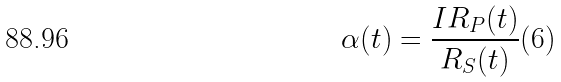Convert formula to latex. <formula><loc_0><loc_0><loc_500><loc_500>\alpha ( t ) = \frac { I R _ { P } ( t ) } { R _ { S } ( t ) } ( 6 )</formula> 